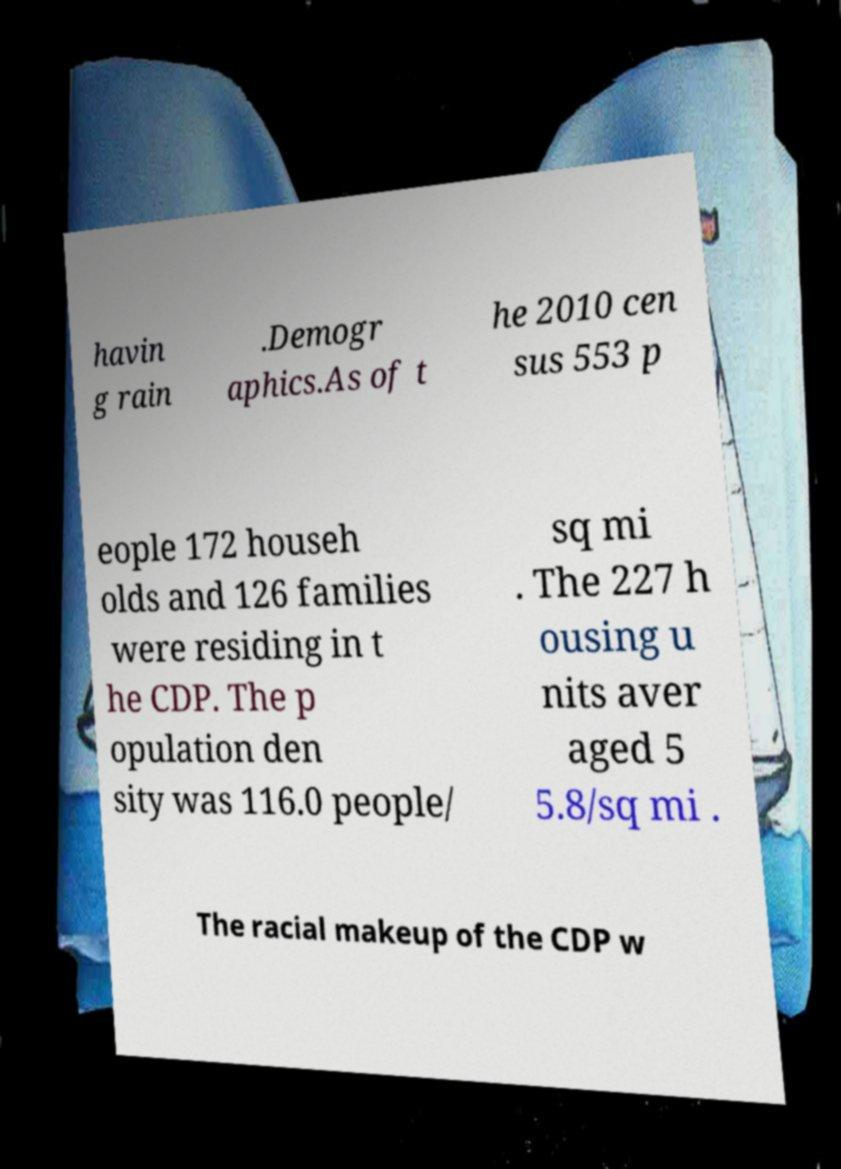I need the written content from this picture converted into text. Can you do that? havin g rain .Demogr aphics.As of t he 2010 cen sus 553 p eople 172 househ olds and 126 families were residing in t he CDP. The p opulation den sity was 116.0 people/ sq mi . The 227 h ousing u nits aver aged 5 5.8/sq mi . The racial makeup of the CDP w 